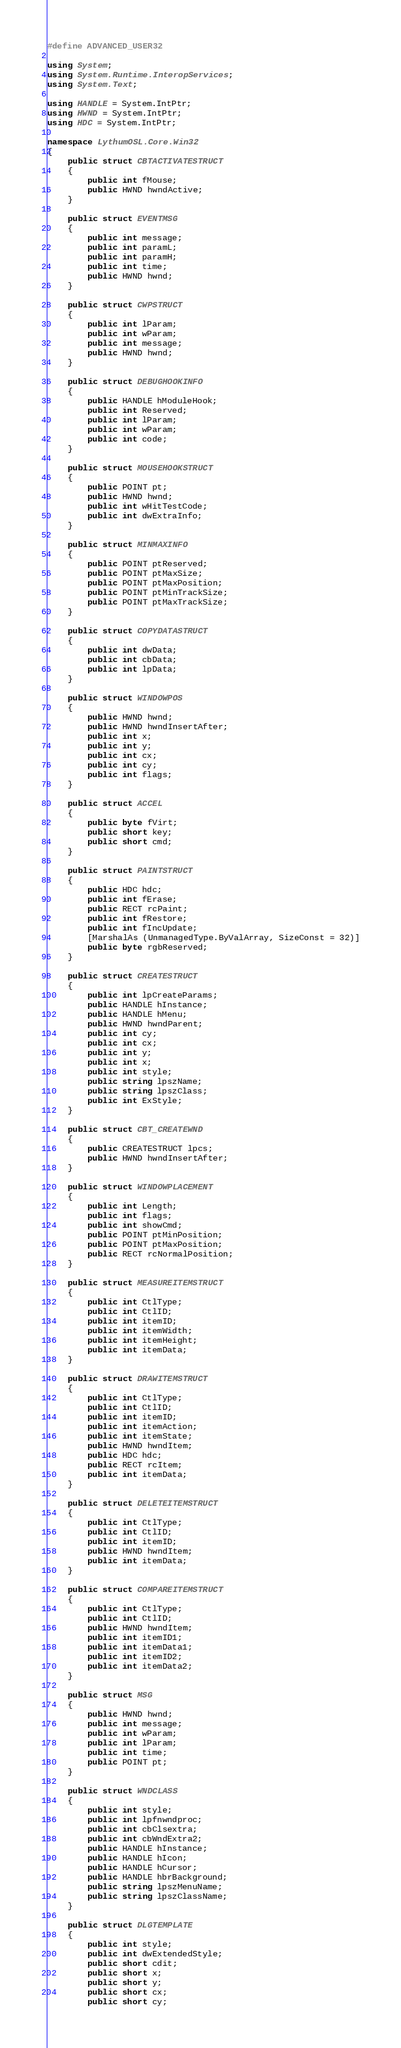<code> <loc_0><loc_0><loc_500><loc_500><_C#_>#define ADVANCED_USER32

using System;
using System.Runtime.InteropServices;
using System.Text;

using HANDLE = System.IntPtr;
using HWND = System.IntPtr;
using HDC = System.IntPtr;

namespace LythumOSL.Core.Win32
{
	public struct CBTACTIVATESTRUCT
	{
		public int fMouse;
		public HWND hwndActive;
	}

	public struct EVENTMSG
	{
		public int message;
		public int paramL;
		public int paramH;
		public int time;
		public HWND hwnd;
	}

	public struct CWPSTRUCT
	{
		public int lParam;
		public int wParam;
		public int message;
		public HWND hwnd;
	}

	public struct DEBUGHOOKINFO
	{
		public HANDLE hModuleHook;
		public int Reserved;
		public int lParam;
		public int wParam;
		public int code;
	}

	public struct MOUSEHOOKSTRUCT
	{
		public POINT pt;
		public HWND hwnd;
		public int wHitTestCode;
		public int dwExtraInfo;
	}

	public struct MINMAXINFO
	{
		public POINT ptReserved;
		public POINT ptMaxSize;
		public POINT ptMaxPosition;
		public POINT ptMinTrackSize;
		public POINT ptMaxTrackSize;
	}

	public struct COPYDATASTRUCT
	{
		public int dwData;
		public int cbData;
		public int lpData;
	}

	public struct WINDOWPOS
	{
		public HWND hwnd;
		public HWND hwndInsertAfter;
		public int x;
		public int y;
		public int cx;
		public int cy;
		public int flags;
	}

	public struct ACCEL
	{
		public byte fVirt;
		public short key;
		public short cmd;
	}

	public struct PAINTSTRUCT
	{
		public HDC hdc;
		public int fErase;
		public RECT rcPaint;
		public int fRestore;
		public int fIncUpdate;
		[MarshalAs (UnmanagedType.ByValArray, SizeConst = 32)]
		public byte rgbReserved;
	}

	public struct CREATESTRUCT
	{
		public int lpCreateParams;
		public HANDLE hInstance;
		public HANDLE hMenu;
		public HWND hwndParent;
		public int cy;
		public int cx;
		public int y;
		public int x;
		public int style;
		public string lpszName;
		public string lpszClass;
		public int ExStyle;
	}

	public struct CBT_CREATEWND
	{
		public CREATESTRUCT lpcs;
		public HWND hwndInsertAfter;
	}

	public struct WINDOWPLACEMENT
	{
		public int Length;
		public int flags;
		public int showCmd;
		public POINT ptMinPosition;
		public POINT ptMaxPosition;
		public RECT rcNormalPosition;
	}

	public struct MEASUREITEMSTRUCT
	{
		public int CtlType;
		public int CtlID;
		public int itemID;
		public int itemWidth;
		public int itemHeight;
		public int itemData;
	}

	public struct DRAWITEMSTRUCT
	{
		public int CtlType;
		public int CtlID;
		public int itemID;
		public int itemAction;
		public int itemState;
		public HWND hwndItem;
		public HDC hdc;
		public RECT rcItem;
		public int itemData;
	}

	public struct DELETEITEMSTRUCT
	{
		public int CtlType;
		public int CtlID;
		public int itemID;
		public HWND hwndItem;
		public int itemData;
	}

	public struct COMPAREITEMSTRUCT
	{
		public int CtlType;
		public int CtlID;
		public HWND hwndItem;
		public int itemID1;
		public int itemData1;
		public int itemID2;
		public int itemData2;
	}

	public struct MSG
	{
		public HWND hwnd;
		public int message;
		public int wParam;
		public int lParam;
		public int time;
		public POINT pt;
	}

	public struct WNDCLASS
	{
		public int style;
		public int lpfnwndproc;
		public int cbClsextra;
		public int cbWndExtra2;
		public HANDLE hInstance;
		public HANDLE hIcon;
		public HANDLE hCursor;
		public HANDLE hbrBackground;
		public string lpszMenuName;
		public string lpszClassName;
	}

	public struct DLGTEMPLATE
	{
		public int style;
		public int dwExtendedStyle;
		public short cdit;
		public short x;
		public short y;
		public short cx;
		public short cy;</code> 